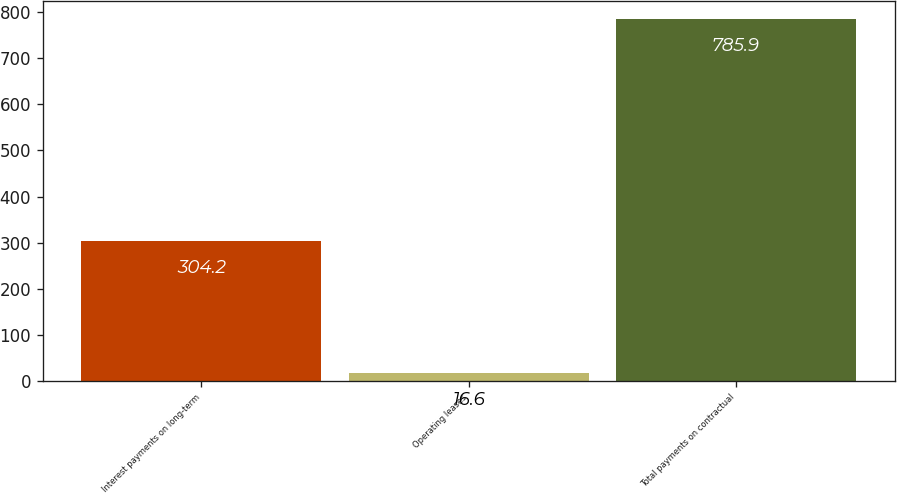Convert chart to OTSL. <chart><loc_0><loc_0><loc_500><loc_500><bar_chart><fcel>Interest payments on long-term<fcel>Operating leases<fcel>Total payments on contractual<nl><fcel>304.2<fcel>16.6<fcel>785.9<nl></chart> 